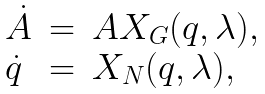Convert formula to latex. <formula><loc_0><loc_0><loc_500><loc_500>\begin{array} { l l l } \dot { A } & = & A X _ { G } ( q , \lambda ) , \\ \dot { q } & = & X _ { N } ( q , \lambda ) , \\ \end{array}</formula> 